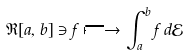Convert formula to latex. <formula><loc_0><loc_0><loc_500><loc_500>\mathfrak { R } [ a , b ] \ni f \longmapsto \int _ { a } ^ { b } f \, d \mathcal { E }</formula> 